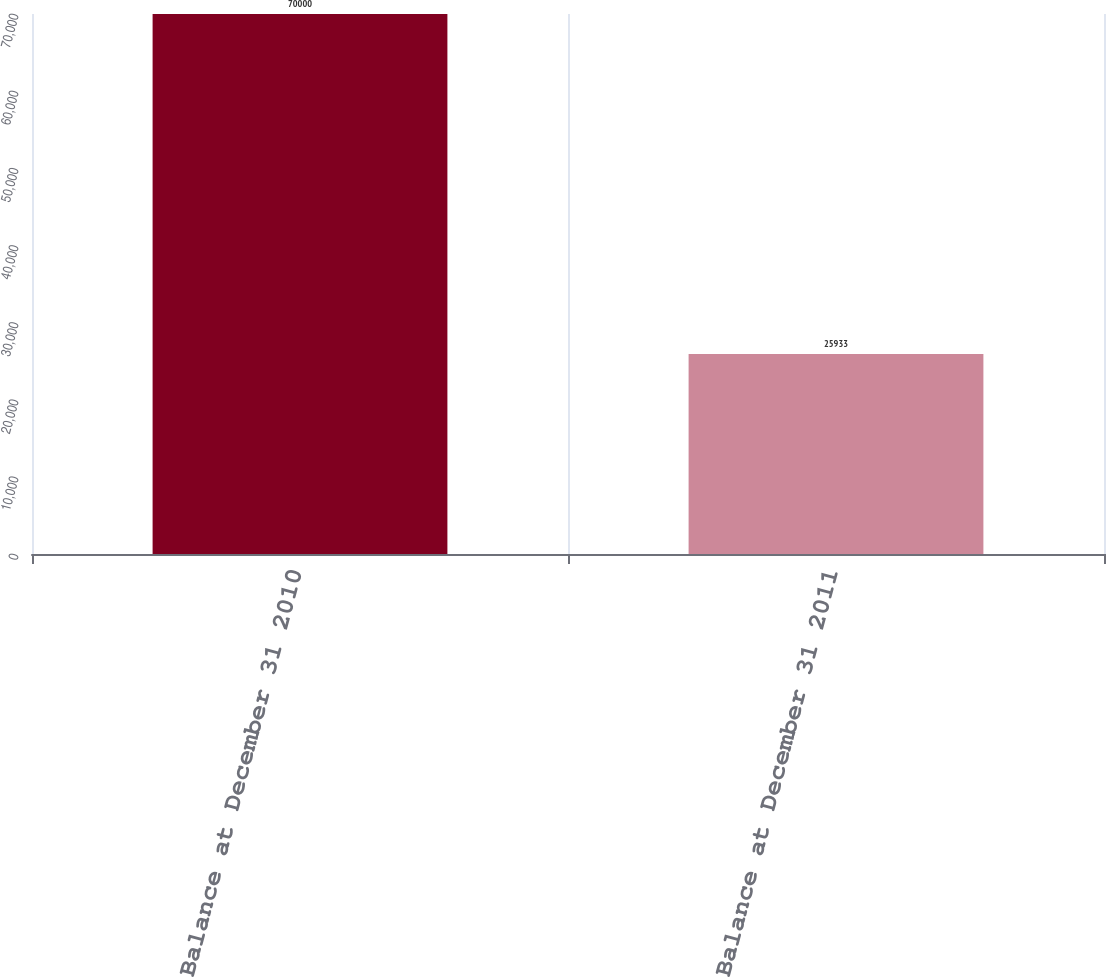<chart> <loc_0><loc_0><loc_500><loc_500><bar_chart><fcel>Balance at December 31 2010<fcel>Balance at December 31 2011<nl><fcel>70000<fcel>25933<nl></chart> 